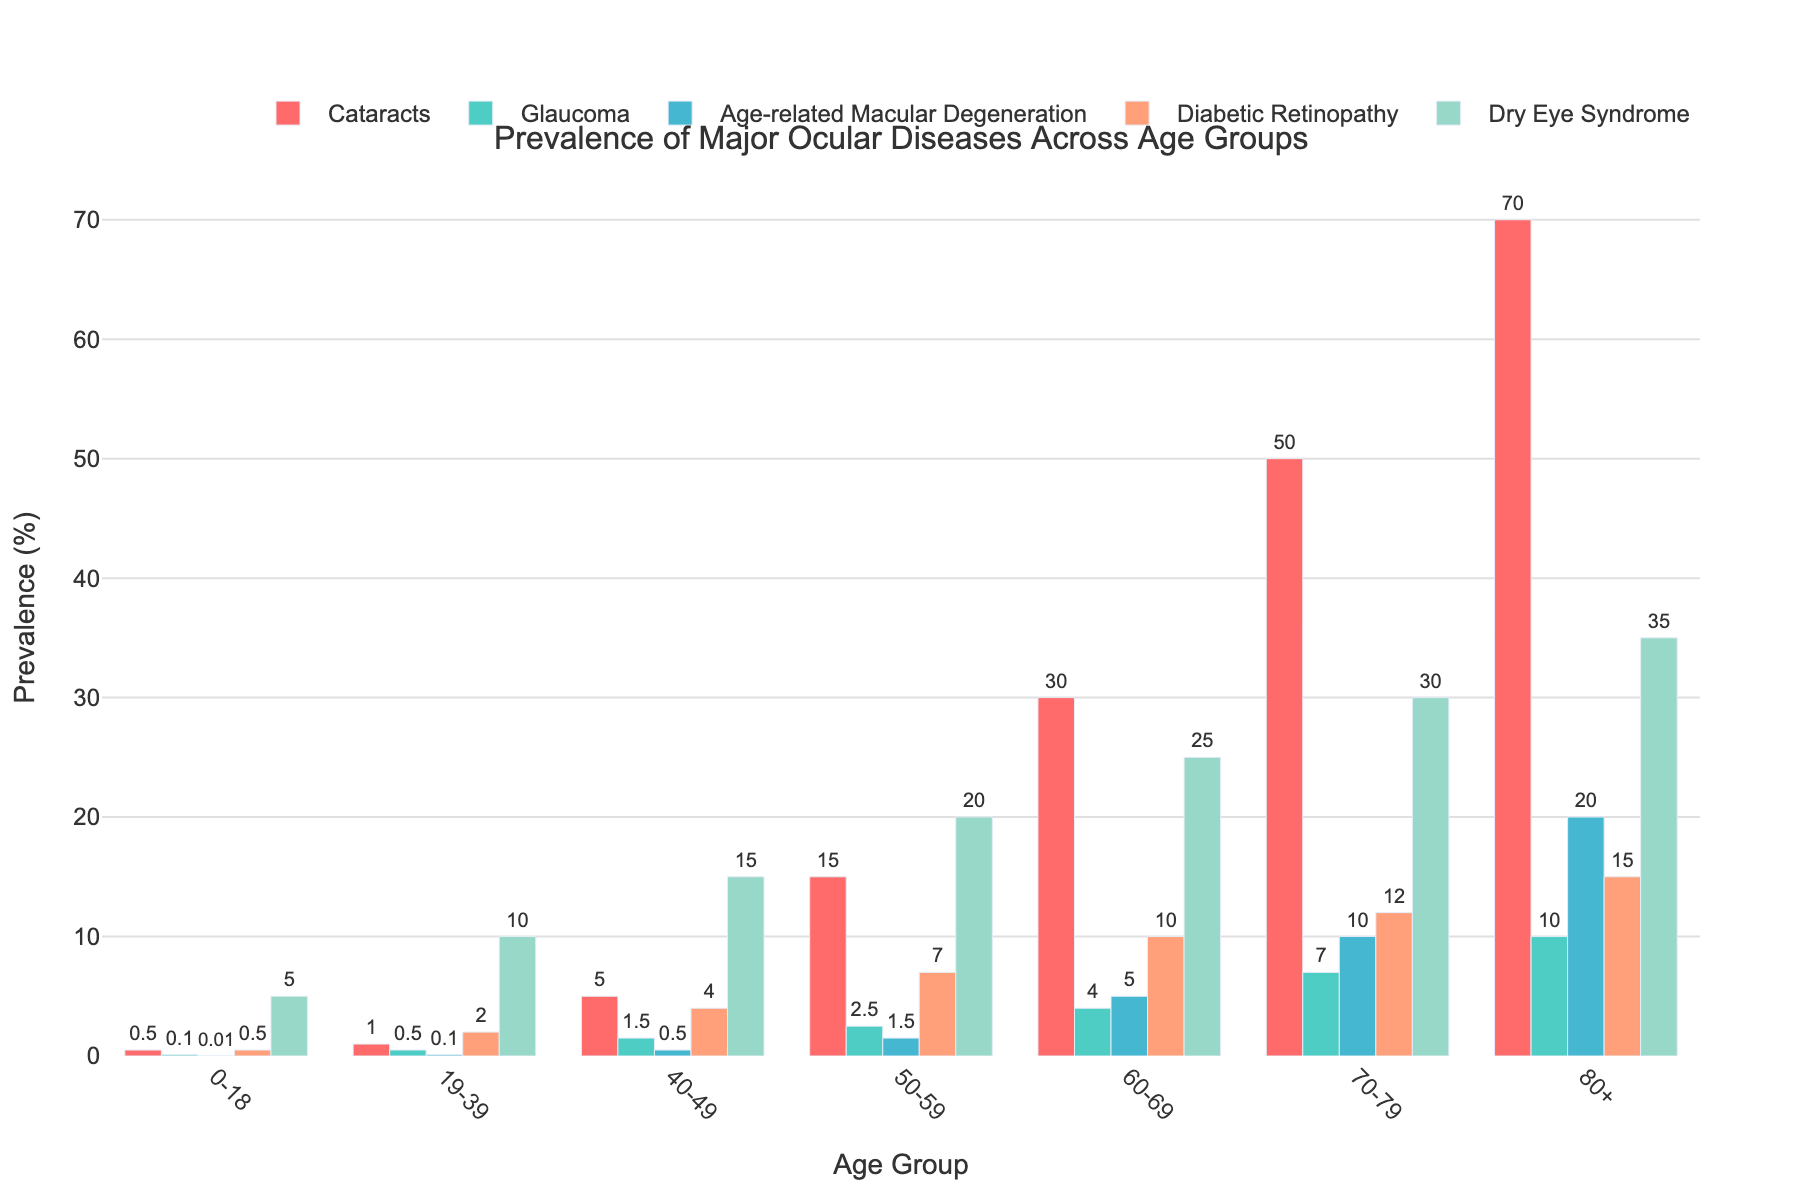Which age group has the highest prevalence of cataracts? By comparing the heights of the bars representing cataracts for each age group, we see that the bar is highest for the 80+ age group.
Answer: 80+ What is the difference in the prevalence of dry eye syndrome between the 40-49 and 50-59 age groups? The prevalence of dry eye syndrome for the 40-49 age group is 15%, and for the 50-59 age group is 20%. The difference is 20% - 15% = 5%.
Answer: 5% Which ocular disease shows the most significant increase in prevalence from the 60-69 age group to the 70-79 age group? By examining the bars, we see the increase for cataracts (30% to 50%), glaucoma (4% to 7%), age-related macular degeneration (5% to 10%), diabetic retinopathy (10% to 12%), and dry eye syndrome (25% to 30%). Cataracts show the most significant increase of 20%.
Answer: Cataracts What is the combined prevalence of glaucoma and diabetic retinopathy in the 19-39 age group? For the 19-39 age group, the prevalence of glaucoma is 0.5% and diabetic retinopathy is 2%. The combined prevalence is 0.5% + 2% = 2.5%.
Answer: 2.5% How does the prevalence of age-related macular degeneration in the 70-79 age group compare to that in the 80+ age group? The prevalence of age-related macular degeneration in the 70-79 age group is 10%, and in the 80+ age group, it is 20%. Thus, the prevalence doubles from the 70-79 age group to the 80+ age group.
Answer: It doubles Which age group has the lowest overall prevalence for all the diseases combined? To find the total combined prevalence for each age group, we need to sum the values for all diseases: 0-18 (0.5+0.1+0.01+0.5+5=6.11), 19-39 (1+0.5+0.1+2+10=13.6), 40-49 (5+1.5+0.5+4+15=26), 50-59 (15+2.5+1.5+7+20=46), 60-69 (30+4+5+10+25=74), 70-79 (50+7+10+12+30=109), 80+ (70+10+20+15+35=150). The 0-18 age group has the lowest combined prevalence of 6.11%.
Answer: 0-18 What is the average prevalence of diabetic retinopathy across all age groups? Summing the prevalence values of diabetic retinopathy: 0.5+2+4+7+10+12+15 = 50. There are 7 age groups, so the average is 50/7 ≈ 7.14%.
Answer: ~7.14% Which ocular disease has the closest prevalence in the 60-69 age group when compared to the 50-59 age group? Comparing the differences in prevalence: Cataracts (30-15=15%), Glaucoma (4-2.5=1.5%), Age-related macular degeneration (5-1.5=3.5%), Diabetic retinopathy (10-7=3%), Dry eye syndrome (25-20=5%). Glaucoma with a difference of 1.5% is the closest.
Answer: Glaucoma What's the median prevalence value of dry eye syndrome across all the age groups? The prevalence values for dry eye syndrome are 5, 10, 15, 20, 25, 30, 35. When sorted, the median is the middle value: 20%.
Answer: 20% 